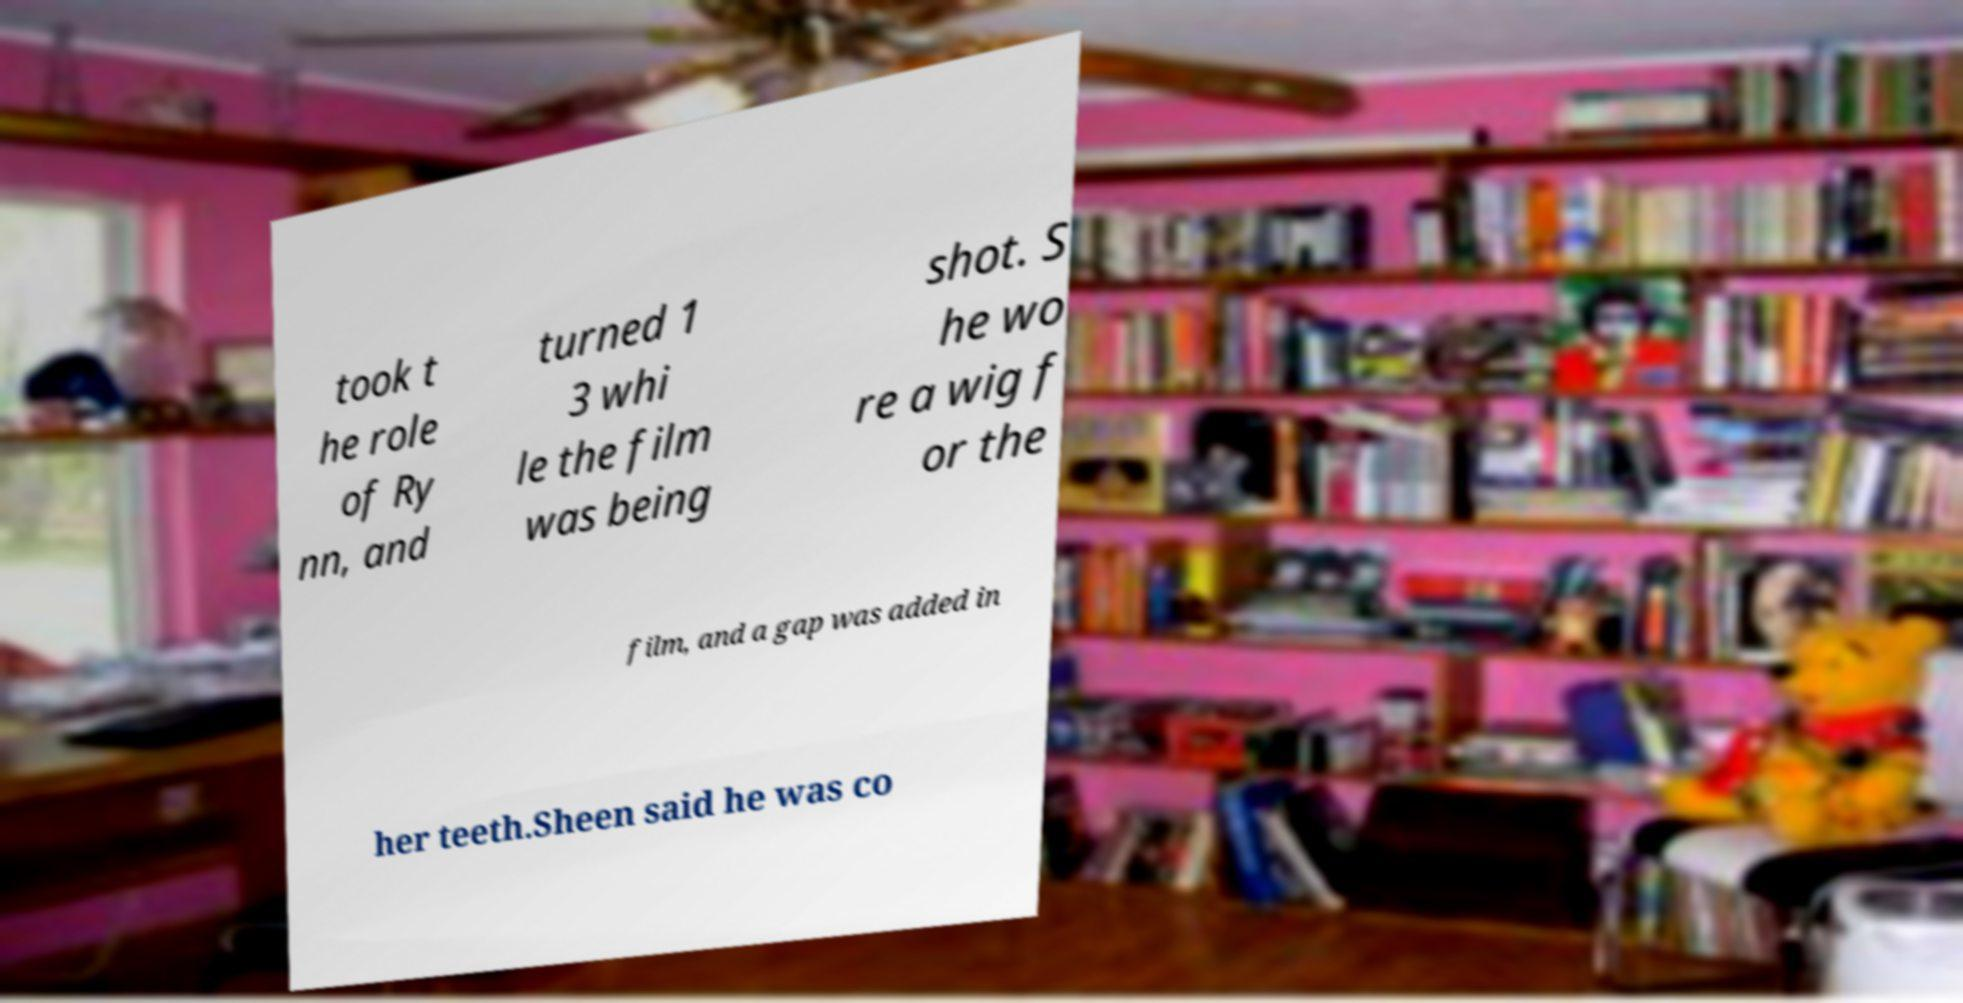I need the written content from this picture converted into text. Can you do that? took t he role of Ry nn, and turned 1 3 whi le the film was being shot. S he wo re a wig f or the film, and a gap was added in her teeth.Sheen said he was co 